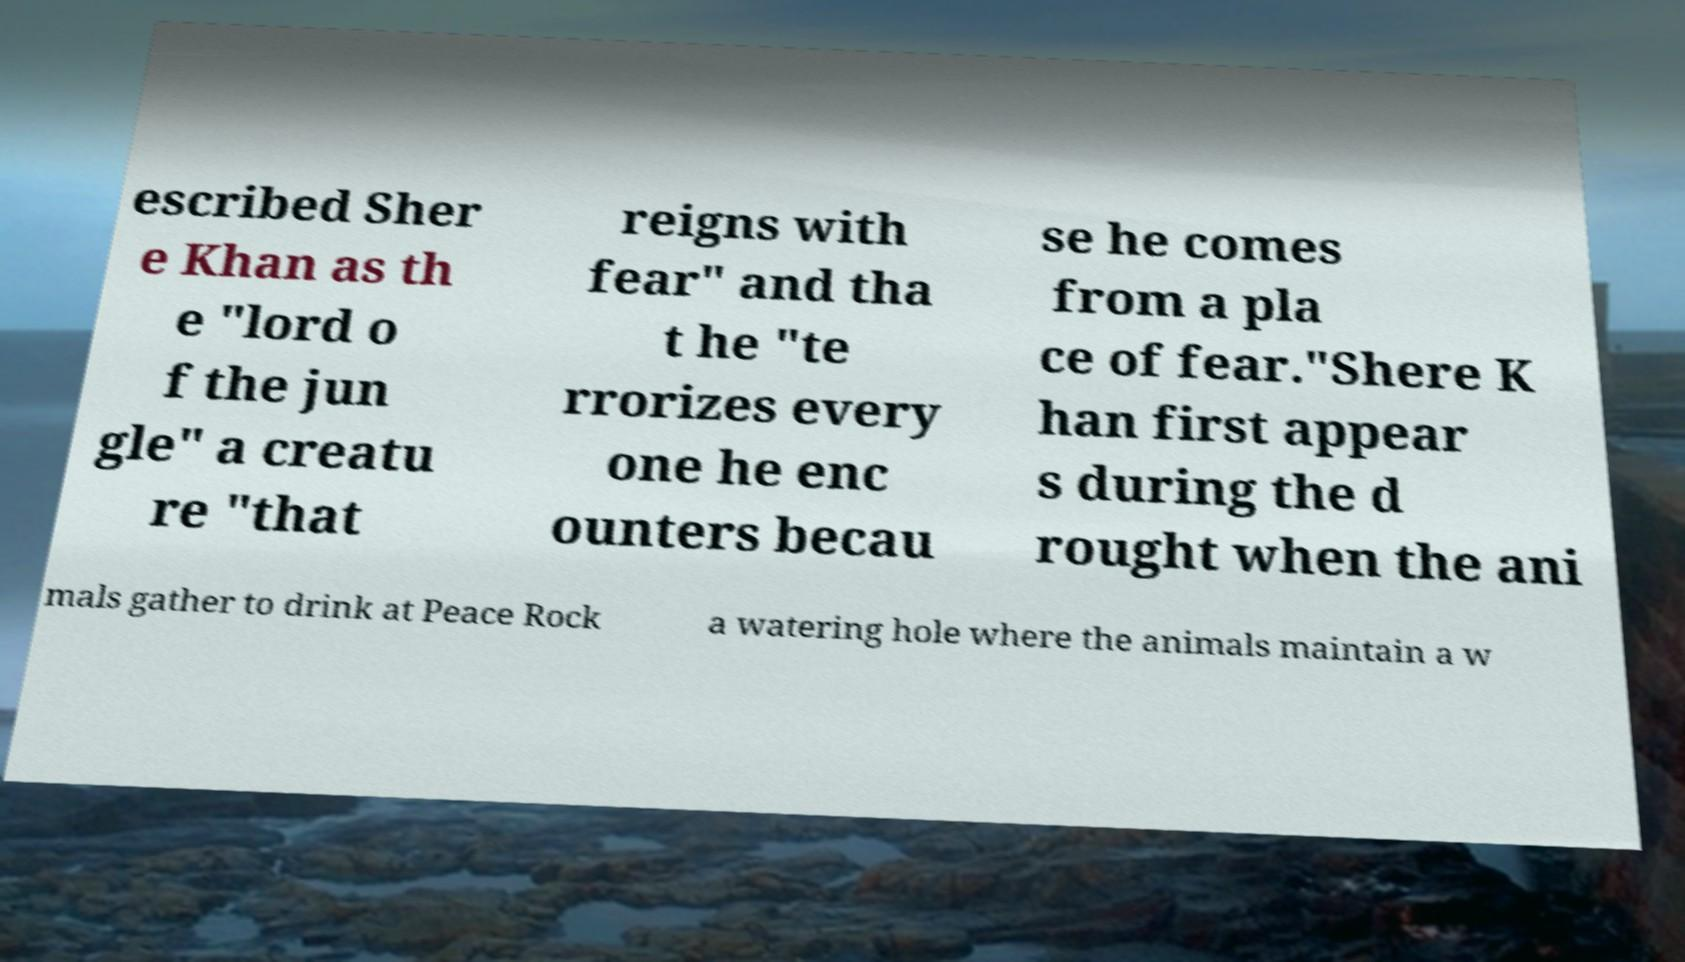Please read and relay the text visible in this image. What does it say? escribed Sher e Khan as th e "lord o f the jun gle" a creatu re "that reigns with fear" and tha t he "te rrorizes every one he enc ounters becau se he comes from a pla ce of fear."Shere K han first appear s during the d rought when the ani mals gather to drink at Peace Rock a watering hole where the animals maintain a w 